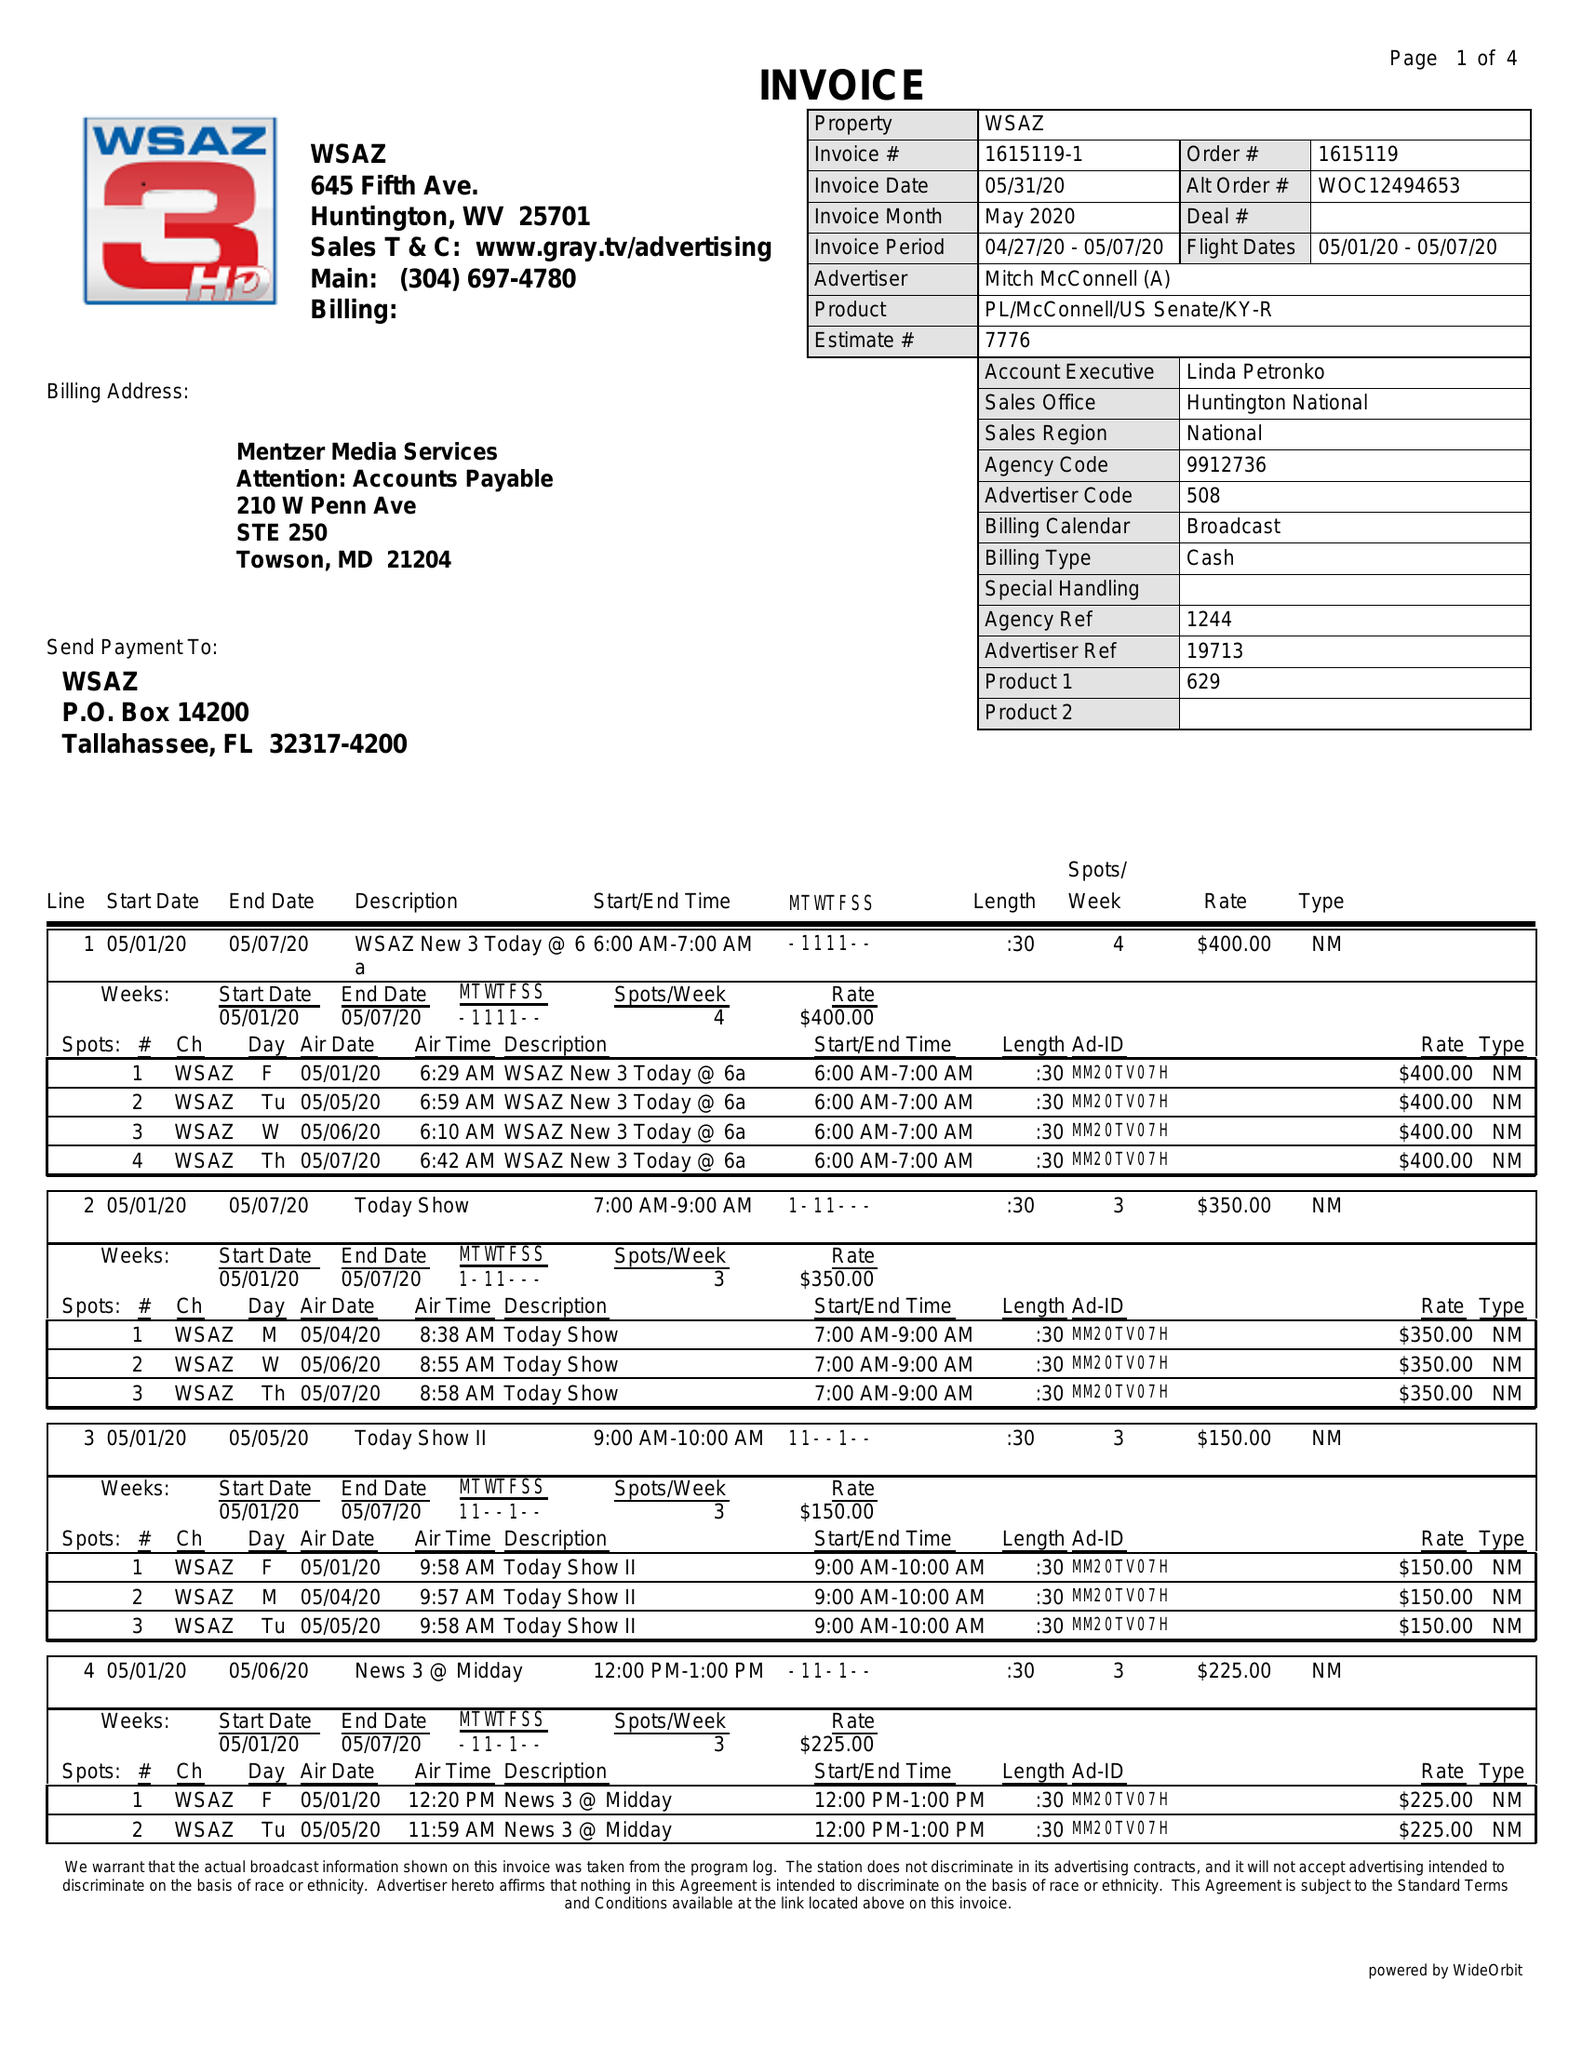What is the value for the flight_to?
Answer the question using a single word or phrase. 05/07/20 